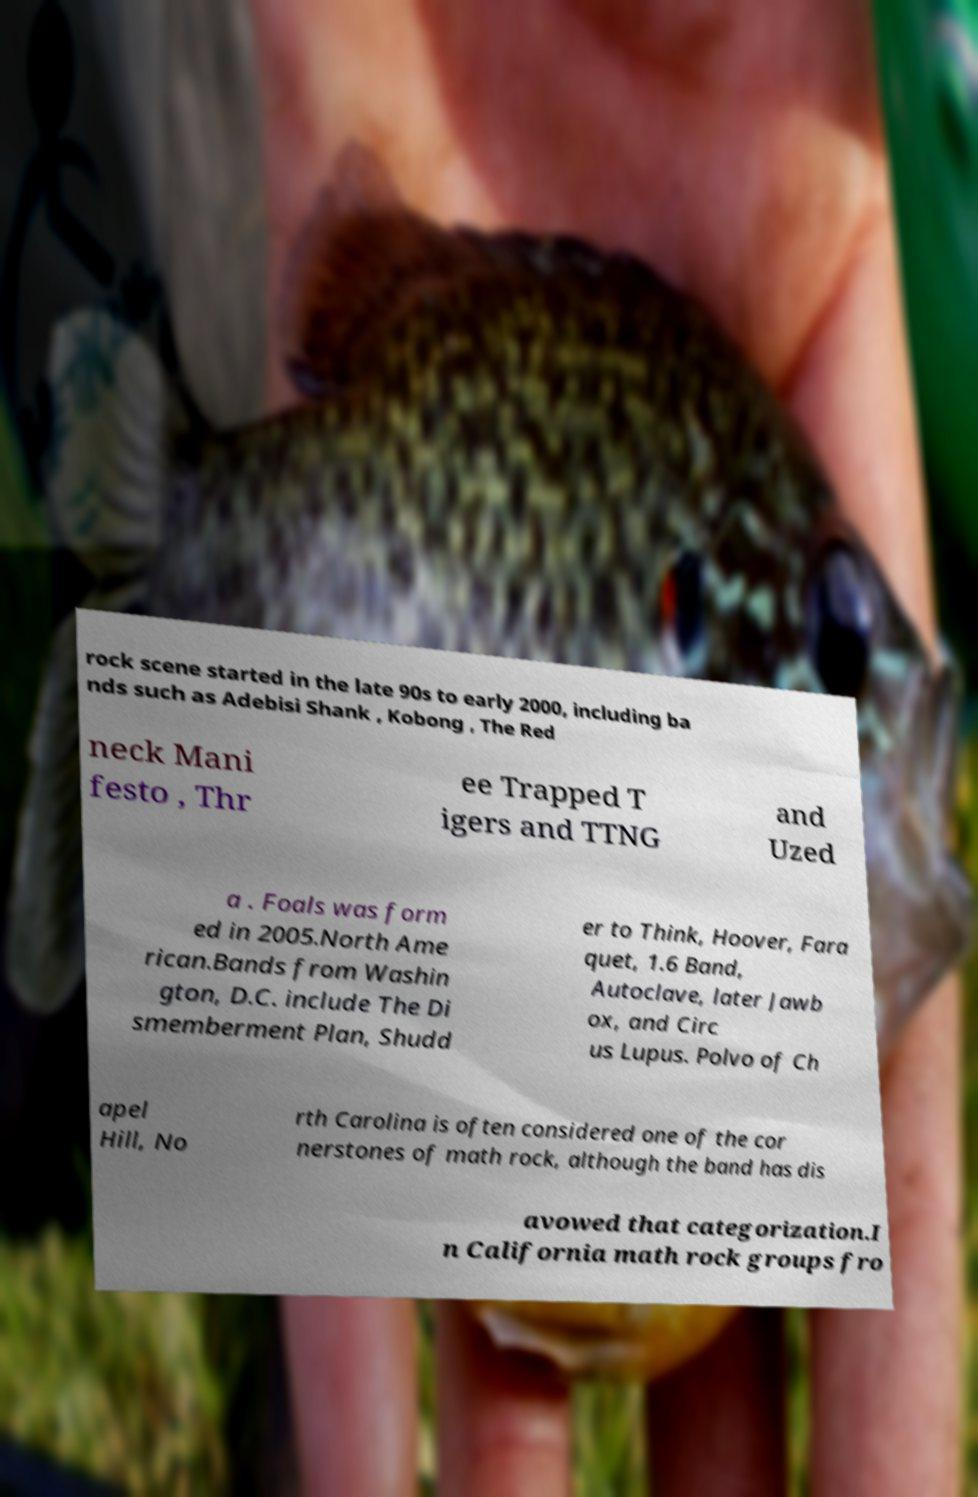Please read and relay the text visible in this image. What does it say? rock scene started in the late 90s to early 2000, including ba nds such as Adebisi Shank , Kobong , The Red neck Mani festo , Thr ee Trapped T igers and TTNG and Uzed a . Foals was form ed in 2005.North Ame rican.Bands from Washin gton, D.C. include The Di smemberment Plan, Shudd er to Think, Hoover, Fara quet, 1.6 Band, Autoclave, later Jawb ox, and Circ us Lupus. Polvo of Ch apel Hill, No rth Carolina is often considered one of the cor nerstones of math rock, although the band has dis avowed that categorization.I n California math rock groups fro 